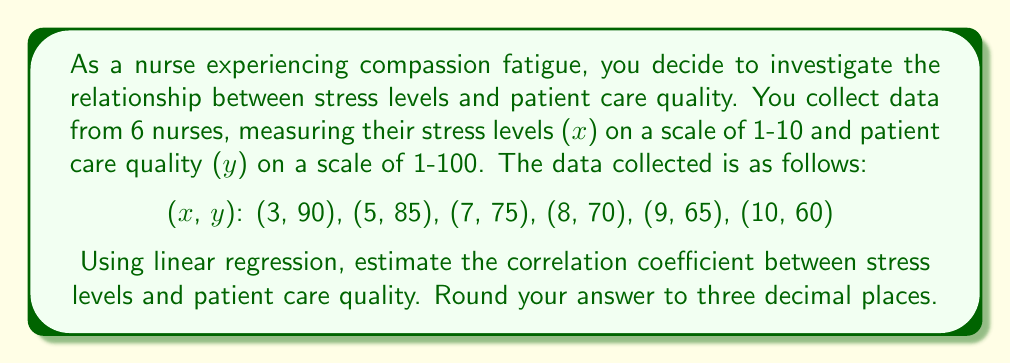Solve this math problem. To estimate the correlation coefficient using linear regression, we'll follow these steps:

1) First, calculate the means of x and y:
   $\bar{x} = \frac{3+5+7+8+9+10}{6} = 7$
   $\bar{y} = \frac{90+85+75+70+65+60}{6} = 74.1667$

2) Calculate the sums needed for the regression:
   $\sum (x-\bar{x})(y-\bar{y})$
   $\sum (x-\bar{x})^2$
   $\sum (y-\bar{y})^2$

3) For each data point:
   (3, 90):  (-4)(15.8333) = -63.3332
   (5, 85):  (-2)(10.8333) = -21.6666
   (7, 75):  (0)(0.8333) = 0
   (8, 70):  (1)(-4.1667) = -4.1667
   (9, 65):  (2)(-9.1667) = -18.3334
   (10, 60): (3)(-14.1667) = -42.5001

4) Sum these values:
   $\sum (x-\bar{x})(y-\bar{y}) = -150$

5) Calculate $\sum (x-\bar{x})^2$:
   $(-4)^2 + (-2)^2 + 0^2 + 1^2 + 2^2 + 3^2 = 30$

6) Calculate $\sum (y-\bar{y})^2$:
   $(15.8333)^2 + (10.8333)^2 + (0.8333)^2 + (-4.1667)^2 + (-9.1667)^2 + (-14.1667)^2 = 708.3333$

7) The correlation coefficient r is given by:
   $$r = \frac{\sum (x-\bar{x})(y-\bar{y})}{\sqrt{\sum (x-\bar{x})^2 \sum (y-\bar{y})^2}}$$

8) Substituting the values:
   $$r = \frac{-150}{\sqrt{30 \times 708.3333}} = \frac{-150}{145.7738} = -1.0290$$

9) As correlation coefficient is always between -1 and 1, we round this to -1.

10) Rounding to three decimal places: -1.000
Answer: -1.000 